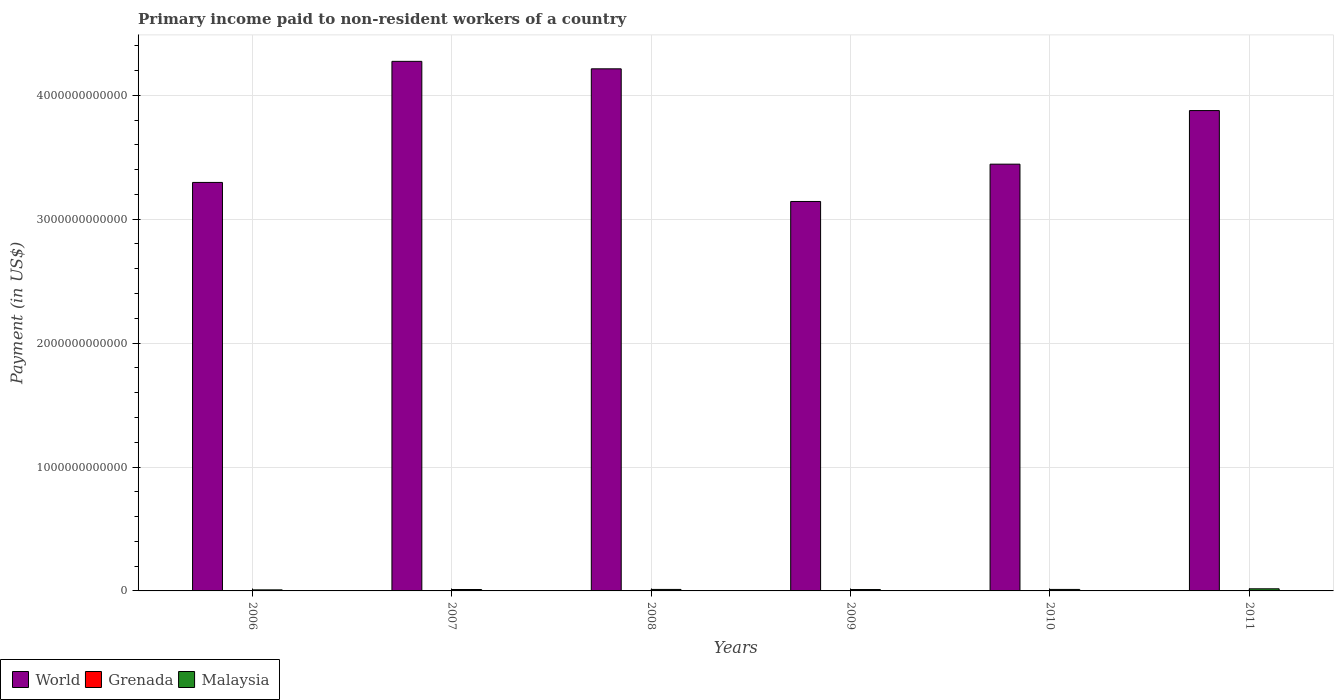How many different coloured bars are there?
Provide a succinct answer. 3. Are the number of bars on each tick of the X-axis equal?
Keep it short and to the point. Yes. How many bars are there on the 4th tick from the right?
Offer a very short reply. 3. What is the amount paid to workers in Grenada in 2007?
Offer a very short reply. 1.37e+07. Across all years, what is the maximum amount paid to workers in Malaysia?
Your answer should be very brief. 1.71e+1. Across all years, what is the minimum amount paid to workers in Malaysia?
Make the answer very short. 8.49e+09. What is the total amount paid to workers in Malaysia in the graph?
Offer a terse response. 7.23e+1. What is the difference between the amount paid to workers in Malaysia in 2009 and that in 2010?
Provide a succinct answer. -7.74e+08. What is the difference between the amount paid to workers in Grenada in 2010 and the amount paid to workers in Malaysia in 2009?
Offer a terse response. -1.12e+1. What is the average amount paid to workers in Grenada per year?
Make the answer very short. 9.34e+06. In the year 2009, what is the difference between the amount paid to workers in World and amount paid to workers in Malaysia?
Offer a very short reply. 3.13e+12. In how many years, is the amount paid to workers in Malaysia greater than 1600000000000 US$?
Keep it short and to the point. 0. What is the ratio of the amount paid to workers in World in 2009 to that in 2010?
Make the answer very short. 0.91. What is the difference between the highest and the second highest amount paid to workers in Grenada?
Provide a short and direct response. 4.04e+05. What is the difference between the highest and the lowest amount paid to workers in Grenada?
Offer a terse response. 7.89e+06. In how many years, is the amount paid to workers in World greater than the average amount paid to workers in World taken over all years?
Make the answer very short. 3. What does the 2nd bar from the left in 2009 represents?
Your answer should be compact. Grenada. What does the 2nd bar from the right in 2010 represents?
Offer a terse response. Grenada. Is it the case that in every year, the sum of the amount paid to workers in Grenada and amount paid to workers in World is greater than the amount paid to workers in Malaysia?
Offer a very short reply. Yes. How many years are there in the graph?
Make the answer very short. 6. What is the difference between two consecutive major ticks on the Y-axis?
Your answer should be very brief. 1.00e+12. Does the graph contain any zero values?
Your answer should be very brief. No. Does the graph contain grids?
Provide a succinct answer. Yes. What is the title of the graph?
Your response must be concise. Primary income paid to non-resident workers of a country. What is the label or title of the Y-axis?
Make the answer very short. Payment (in US$). What is the Payment (in US$) of World in 2006?
Give a very brief answer. 3.30e+12. What is the Payment (in US$) in Grenada in 2006?
Offer a terse response. 1.33e+07. What is the Payment (in US$) in Malaysia in 2006?
Your response must be concise. 8.49e+09. What is the Payment (in US$) in World in 2007?
Your answer should be very brief. 4.27e+12. What is the Payment (in US$) in Grenada in 2007?
Make the answer very short. 1.37e+07. What is the Payment (in US$) in Malaysia in 2007?
Your response must be concise. 1.14e+1. What is the Payment (in US$) of World in 2008?
Provide a short and direct response. 4.21e+12. What is the Payment (in US$) in Grenada in 2008?
Make the answer very short. 8.08e+06. What is the Payment (in US$) in Malaysia in 2008?
Your answer should be very brief. 1.21e+1. What is the Payment (in US$) in World in 2009?
Give a very brief answer. 3.14e+12. What is the Payment (in US$) of Grenada in 2009?
Offer a terse response. 8.12e+06. What is the Payment (in US$) in Malaysia in 2009?
Your answer should be very brief. 1.12e+1. What is the Payment (in US$) in World in 2010?
Provide a succinct answer. 3.44e+12. What is the Payment (in US$) in Grenada in 2010?
Your answer should be compact. 7.15e+06. What is the Payment (in US$) in Malaysia in 2010?
Your response must be concise. 1.20e+1. What is the Payment (in US$) in World in 2011?
Keep it short and to the point. 3.88e+12. What is the Payment (in US$) of Grenada in 2011?
Provide a short and direct response. 5.77e+06. What is the Payment (in US$) of Malaysia in 2011?
Offer a terse response. 1.71e+1. Across all years, what is the maximum Payment (in US$) in World?
Provide a succinct answer. 4.27e+12. Across all years, what is the maximum Payment (in US$) of Grenada?
Your response must be concise. 1.37e+07. Across all years, what is the maximum Payment (in US$) in Malaysia?
Make the answer very short. 1.71e+1. Across all years, what is the minimum Payment (in US$) in World?
Provide a short and direct response. 3.14e+12. Across all years, what is the minimum Payment (in US$) in Grenada?
Offer a very short reply. 5.77e+06. Across all years, what is the minimum Payment (in US$) in Malaysia?
Keep it short and to the point. 8.49e+09. What is the total Payment (in US$) in World in the graph?
Your response must be concise. 2.22e+13. What is the total Payment (in US$) of Grenada in the graph?
Your answer should be compact. 5.60e+07. What is the total Payment (in US$) of Malaysia in the graph?
Ensure brevity in your answer.  7.23e+1. What is the difference between the Payment (in US$) of World in 2006 and that in 2007?
Give a very brief answer. -9.77e+11. What is the difference between the Payment (in US$) of Grenada in 2006 and that in 2007?
Make the answer very short. -4.04e+05. What is the difference between the Payment (in US$) of Malaysia in 2006 and that in 2007?
Give a very brief answer. -2.89e+09. What is the difference between the Payment (in US$) in World in 2006 and that in 2008?
Make the answer very short. -9.17e+11. What is the difference between the Payment (in US$) in Grenada in 2006 and that in 2008?
Make the answer very short. 5.17e+06. What is the difference between the Payment (in US$) in Malaysia in 2006 and that in 2008?
Offer a very short reply. -3.59e+09. What is the difference between the Payment (in US$) in World in 2006 and that in 2009?
Keep it short and to the point. 1.54e+11. What is the difference between the Payment (in US$) in Grenada in 2006 and that in 2009?
Your answer should be compact. 5.13e+06. What is the difference between the Payment (in US$) in Malaysia in 2006 and that in 2009?
Offer a terse response. -2.72e+09. What is the difference between the Payment (in US$) of World in 2006 and that in 2010?
Offer a terse response. -1.47e+11. What is the difference between the Payment (in US$) in Grenada in 2006 and that in 2010?
Your answer should be very brief. 6.10e+06. What is the difference between the Payment (in US$) of Malaysia in 2006 and that in 2010?
Your answer should be very brief. -3.49e+09. What is the difference between the Payment (in US$) in World in 2006 and that in 2011?
Make the answer very short. -5.80e+11. What is the difference between the Payment (in US$) of Grenada in 2006 and that in 2011?
Provide a succinct answer. 7.49e+06. What is the difference between the Payment (in US$) of Malaysia in 2006 and that in 2011?
Give a very brief answer. -8.64e+09. What is the difference between the Payment (in US$) of World in 2007 and that in 2008?
Provide a succinct answer. 6.03e+1. What is the difference between the Payment (in US$) in Grenada in 2007 and that in 2008?
Your answer should be very brief. 5.58e+06. What is the difference between the Payment (in US$) of Malaysia in 2007 and that in 2008?
Ensure brevity in your answer.  -7.01e+08. What is the difference between the Payment (in US$) of World in 2007 and that in 2009?
Your answer should be compact. 1.13e+12. What is the difference between the Payment (in US$) in Grenada in 2007 and that in 2009?
Provide a short and direct response. 5.54e+06. What is the difference between the Payment (in US$) in Malaysia in 2007 and that in 2009?
Your answer should be compact. 1.67e+08. What is the difference between the Payment (in US$) of World in 2007 and that in 2010?
Make the answer very short. 8.30e+11. What is the difference between the Payment (in US$) in Grenada in 2007 and that in 2010?
Your answer should be compact. 6.51e+06. What is the difference between the Payment (in US$) of Malaysia in 2007 and that in 2010?
Ensure brevity in your answer.  -6.07e+08. What is the difference between the Payment (in US$) of World in 2007 and that in 2011?
Ensure brevity in your answer.  3.97e+11. What is the difference between the Payment (in US$) of Grenada in 2007 and that in 2011?
Offer a terse response. 7.89e+06. What is the difference between the Payment (in US$) of Malaysia in 2007 and that in 2011?
Your response must be concise. -5.75e+09. What is the difference between the Payment (in US$) in World in 2008 and that in 2009?
Keep it short and to the point. 1.07e+12. What is the difference between the Payment (in US$) in Grenada in 2008 and that in 2009?
Your answer should be very brief. -4.16e+04. What is the difference between the Payment (in US$) of Malaysia in 2008 and that in 2009?
Offer a terse response. 8.69e+08. What is the difference between the Payment (in US$) in World in 2008 and that in 2010?
Your answer should be very brief. 7.69e+11. What is the difference between the Payment (in US$) of Grenada in 2008 and that in 2010?
Provide a short and direct response. 9.31e+05. What is the difference between the Payment (in US$) of Malaysia in 2008 and that in 2010?
Give a very brief answer. 9.47e+07. What is the difference between the Payment (in US$) in World in 2008 and that in 2011?
Provide a short and direct response. 3.37e+11. What is the difference between the Payment (in US$) of Grenada in 2008 and that in 2011?
Your answer should be compact. 2.31e+06. What is the difference between the Payment (in US$) in Malaysia in 2008 and that in 2011?
Offer a terse response. -5.05e+09. What is the difference between the Payment (in US$) in World in 2009 and that in 2010?
Give a very brief answer. -3.01e+11. What is the difference between the Payment (in US$) of Grenada in 2009 and that in 2010?
Make the answer very short. 9.73e+05. What is the difference between the Payment (in US$) of Malaysia in 2009 and that in 2010?
Give a very brief answer. -7.74e+08. What is the difference between the Payment (in US$) in World in 2009 and that in 2011?
Your response must be concise. -7.34e+11. What is the difference between the Payment (in US$) in Grenada in 2009 and that in 2011?
Your response must be concise. 2.35e+06. What is the difference between the Payment (in US$) of Malaysia in 2009 and that in 2011?
Your answer should be compact. -5.92e+09. What is the difference between the Payment (in US$) in World in 2010 and that in 2011?
Give a very brief answer. -4.33e+11. What is the difference between the Payment (in US$) in Grenada in 2010 and that in 2011?
Your answer should be compact. 1.38e+06. What is the difference between the Payment (in US$) in Malaysia in 2010 and that in 2011?
Offer a very short reply. -5.15e+09. What is the difference between the Payment (in US$) of World in 2006 and the Payment (in US$) of Grenada in 2007?
Your answer should be compact. 3.30e+12. What is the difference between the Payment (in US$) of World in 2006 and the Payment (in US$) of Malaysia in 2007?
Your answer should be very brief. 3.29e+12. What is the difference between the Payment (in US$) of Grenada in 2006 and the Payment (in US$) of Malaysia in 2007?
Ensure brevity in your answer.  -1.14e+1. What is the difference between the Payment (in US$) of World in 2006 and the Payment (in US$) of Grenada in 2008?
Your answer should be compact. 3.30e+12. What is the difference between the Payment (in US$) of World in 2006 and the Payment (in US$) of Malaysia in 2008?
Your answer should be compact. 3.28e+12. What is the difference between the Payment (in US$) in Grenada in 2006 and the Payment (in US$) in Malaysia in 2008?
Keep it short and to the point. -1.21e+1. What is the difference between the Payment (in US$) of World in 2006 and the Payment (in US$) of Grenada in 2009?
Keep it short and to the point. 3.30e+12. What is the difference between the Payment (in US$) of World in 2006 and the Payment (in US$) of Malaysia in 2009?
Keep it short and to the point. 3.29e+12. What is the difference between the Payment (in US$) of Grenada in 2006 and the Payment (in US$) of Malaysia in 2009?
Provide a short and direct response. -1.12e+1. What is the difference between the Payment (in US$) in World in 2006 and the Payment (in US$) in Grenada in 2010?
Ensure brevity in your answer.  3.30e+12. What is the difference between the Payment (in US$) in World in 2006 and the Payment (in US$) in Malaysia in 2010?
Your response must be concise. 3.28e+12. What is the difference between the Payment (in US$) in Grenada in 2006 and the Payment (in US$) in Malaysia in 2010?
Your answer should be very brief. -1.20e+1. What is the difference between the Payment (in US$) of World in 2006 and the Payment (in US$) of Grenada in 2011?
Offer a terse response. 3.30e+12. What is the difference between the Payment (in US$) in World in 2006 and the Payment (in US$) in Malaysia in 2011?
Provide a succinct answer. 3.28e+12. What is the difference between the Payment (in US$) in Grenada in 2006 and the Payment (in US$) in Malaysia in 2011?
Keep it short and to the point. -1.71e+1. What is the difference between the Payment (in US$) of World in 2007 and the Payment (in US$) of Grenada in 2008?
Keep it short and to the point. 4.27e+12. What is the difference between the Payment (in US$) in World in 2007 and the Payment (in US$) in Malaysia in 2008?
Offer a very short reply. 4.26e+12. What is the difference between the Payment (in US$) of Grenada in 2007 and the Payment (in US$) of Malaysia in 2008?
Make the answer very short. -1.21e+1. What is the difference between the Payment (in US$) of World in 2007 and the Payment (in US$) of Grenada in 2009?
Make the answer very short. 4.27e+12. What is the difference between the Payment (in US$) in World in 2007 and the Payment (in US$) in Malaysia in 2009?
Keep it short and to the point. 4.26e+12. What is the difference between the Payment (in US$) in Grenada in 2007 and the Payment (in US$) in Malaysia in 2009?
Provide a short and direct response. -1.12e+1. What is the difference between the Payment (in US$) in World in 2007 and the Payment (in US$) in Grenada in 2010?
Your answer should be very brief. 4.27e+12. What is the difference between the Payment (in US$) of World in 2007 and the Payment (in US$) of Malaysia in 2010?
Your response must be concise. 4.26e+12. What is the difference between the Payment (in US$) in Grenada in 2007 and the Payment (in US$) in Malaysia in 2010?
Ensure brevity in your answer.  -1.20e+1. What is the difference between the Payment (in US$) in World in 2007 and the Payment (in US$) in Grenada in 2011?
Provide a succinct answer. 4.27e+12. What is the difference between the Payment (in US$) of World in 2007 and the Payment (in US$) of Malaysia in 2011?
Keep it short and to the point. 4.26e+12. What is the difference between the Payment (in US$) of Grenada in 2007 and the Payment (in US$) of Malaysia in 2011?
Provide a succinct answer. -1.71e+1. What is the difference between the Payment (in US$) of World in 2008 and the Payment (in US$) of Grenada in 2009?
Your answer should be very brief. 4.21e+12. What is the difference between the Payment (in US$) of World in 2008 and the Payment (in US$) of Malaysia in 2009?
Your response must be concise. 4.20e+12. What is the difference between the Payment (in US$) in Grenada in 2008 and the Payment (in US$) in Malaysia in 2009?
Your response must be concise. -1.12e+1. What is the difference between the Payment (in US$) of World in 2008 and the Payment (in US$) of Grenada in 2010?
Offer a terse response. 4.21e+12. What is the difference between the Payment (in US$) of World in 2008 and the Payment (in US$) of Malaysia in 2010?
Your answer should be compact. 4.20e+12. What is the difference between the Payment (in US$) of Grenada in 2008 and the Payment (in US$) of Malaysia in 2010?
Ensure brevity in your answer.  -1.20e+1. What is the difference between the Payment (in US$) of World in 2008 and the Payment (in US$) of Grenada in 2011?
Keep it short and to the point. 4.21e+12. What is the difference between the Payment (in US$) in World in 2008 and the Payment (in US$) in Malaysia in 2011?
Your answer should be compact. 4.20e+12. What is the difference between the Payment (in US$) of Grenada in 2008 and the Payment (in US$) of Malaysia in 2011?
Offer a very short reply. -1.71e+1. What is the difference between the Payment (in US$) of World in 2009 and the Payment (in US$) of Grenada in 2010?
Make the answer very short. 3.14e+12. What is the difference between the Payment (in US$) in World in 2009 and the Payment (in US$) in Malaysia in 2010?
Keep it short and to the point. 3.13e+12. What is the difference between the Payment (in US$) in Grenada in 2009 and the Payment (in US$) in Malaysia in 2010?
Make the answer very short. -1.20e+1. What is the difference between the Payment (in US$) of World in 2009 and the Payment (in US$) of Grenada in 2011?
Give a very brief answer. 3.14e+12. What is the difference between the Payment (in US$) of World in 2009 and the Payment (in US$) of Malaysia in 2011?
Make the answer very short. 3.13e+12. What is the difference between the Payment (in US$) of Grenada in 2009 and the Payment (in US$) of Malaysia in 2011?
Provide a short and direct response. -1.71e+1. What is the difference between the Payment (in US$) of World in 2010 and the Payment (in US$) of Grenada in 2011?
Provide a succinct answer. 3.44e+12. What is the difference between the Payment (in US$) of World in 2010 and the Payment (in US$) of Malaysia in 2011?
Your response must be concise. 3.43e+12. What is the difference between the Payment (in US$) in Grenada in 2010 and the Payment (in US$) in Malaysia in 2011?
Offer a very short reply. -1.71e+1. What is the average Payment (in US$) of World per year?
Your answer should be compact. 3.71e+12. What is the average Payment (in US$) of Grenada per year?
Your answer should be compact. 9.34e+06. What is the average Payment (in US$) in Malaysia per year?
Ensure brevity in your answer.  1.20e+1. In the year 2006, what is the difference between the Payment (in US$) of World and Payment (in US$) of Grenada?
Provide a succinct answer. 3.30e+12. In the year 2006, what is the difference between the Payment (in US$) in World and Payment (in US$) in Malaysia?
Your answer should be compact. 3.29e+12. In the year 2006, what is the difference between the Payment (in US$) in Grenada and Payment (in US$) in Malaysia?
Your response must be concise. -8.48e+09. In the year 2007, what is the difference between the Payment (in US$) in World and Payment (in US$) in Grenada?
Your answer should be very brief. 4.27e+12. In the year 2007, what is the difference between the Payment (in US$) of World and Payment (in US$) of Malaysia?
Your answer should be compact. 4.26e+12. In the year 2007, what is the difference between the Payment (in US$) of Grenada and Payment (in US$) of Malaysia?
Keep it short and to the point. -1.14e+1. In the year 2008, what is the difference between the Payment (in US$) of World and Payment (in US$) of Grenada?
Give a very brief answer. 4.21e+12. In the year 2008, what is the difference between the Payment (in US$) in World and Payment (in US$) in Malaysia?
Give a very brief answer. 4.20e+12. In the year 2008, what is the difference between the Payment (in US$) of Grenada and Payment (in US$) of Malaysia?
Ensure brevity in your answer.  -1.21e+1. In the year 2009, what is the difference between the Payment (in US$) in World and Payment (in US$) in Grenada?
Provide a succinct answer. 3.14e+12. In the year 2009, what is the difference between the Payment (in US$) in World and Payment (in US$) in Malaysia?
Offer a very short reply. 3.13e+12. In the year 2009, what is the difference between the Payment (in US$) of Grenada and Payment (in US$) of Malaysia?
Ensure brevity in your answer.  -1.12e+1. In the year 2010, what is the difference between the Payment (in US$) of World and Payment (in US$) of Grenada?
Make the answer very short. 3.44e+12. In the year 2010, what is the difference between the Payment (in US$) in World and Payment (in US$) in Malaysia?
Offer a very short reply. 3.43e+12. In the year 2010, what is the difference between the Payment (in US$) in Grenada and Payment (in US$) in Malaysia?
Provide a short and direct response. -1.20e+1. In the year 2011, what is the difference between the Payment (in US$) in World and Payment (in US$) in Grenada?
Ensure brevity in your answer.  3.88e+12. In the year 2011, what is the difference between the Payment (in US$) of World and Payment (in US$) of Malaysia?
Ensure brevity in your answer.  3.86e+12. In the year 2011, what is the difference between the Payment (in US$) of Grenada and Payment (in US$) of Malaysia?
Provide a short and direct response. -1.71e+1. What is the ratio of the Payment (in US$) of World in 2006 to that in 2007?
Provide a short and direct response. 0.77. What is the ratio of the Payment (in US$) of Grenada in 2006 to that in 2007?
Offer a terse response. 0.97. What is the ratio of the Payment (in US$) of Malaysia in 2006 to that in 2007?
Your answer should be very brief. 0.75. What is the ratio of the Payment (in US$) in World in 2006 to that in 2008?
Give a very brief answer. 0.78. What is the ratio of the Payment (in US$) in Grenada in 2006 to that in 2008?
Ensure brevity in your answer.  1.64. What is the ratio of the Payment (in US$) in Malaysia in 2006 to that in 2008?
Make the answer very short. 0.7. What is the ratio of the Payment (in US$) of World in 2006 to that in 2009?
Make the answer very short. 1.05. What is the ratio of the Payment (in US$) in Grenada in 2006 to that in 2009?
Your answer should be compact. 1.63. What is the ratio of the Payment (in US$) in Malaysia in 2006 to that in 2009?
Ensure brevity in your answer.  0.76. What is the ratio of the Payment (in US$) in World in 2006 to that in 2010?
Your response must be concise. 0.96. What is the ratio of the Payment (in US$) of Grenada in 2006 to that in 2010?
Your answer should be very brief. 1.85. What is the ratio of the Payment (in US$) in Malaysia in 2006 to that in 2010?
Your answer should be compact. 0.71. What is the ratio of the Payment (in US$) in World in 2006 to that in 2011?
Provide a succinct answer. 0.85. What is the ratio of the Payment (in US$) in Grenada in 2006 to that in 2011?
Keep it short and to the point. 2.3. What is the ratio of the Payment (in US$) in Malaysia in 2006 to that in 2011?
Ensure brevity in your answer.  0.5. What is the ratio of the Payment (in US$) in World in 2007 to that in 2008?
Offer a terse response. 1.01. What is the ratio of the Payment (in US$) of Grenada in 2007 to that in 2008?
Your answer should be compact. 1.69. What is the ratio of the Payment (in US$) of Malaysia in 2007 to that in 2008?
Your answer should be compact. 0.94. What is the ratio of the Payment (in US$) of World in 2007 to that in 2009?
Make the answer very short. 1.36. What is the ratio of the Payment (in US$) in Grenada in 2007 to that in 2009?
Keep it short and to the point. 1.68. What is the ratio of the Payment (in US$) in Malaysia in 2007 to that in 2009?
Keep it short and to the point. 1.01. What is the ratio of the Payment (in US$) in World in 2007 to that in 2010?
Keep it short and to the point. 1.24. What is the ratio of the Payment (in US$) of Grenada in 2007 to that in 2010?
Provide a succinct answer. 1.91. What is the ratio of the Payment (in US$) of Malaysia in 2007 to that in 2010?
Offer a very short reply. 0.95. What is the ratio of the Payment (in US$) in World in 2007 to that in 2011?
Ensure brevity in your answer.  1.1. What is the ratio of the Payment (in US$) in Grenada in 2007 to that in 2011?
Keep it short and to the point. 2.37. What is the ratio of the Payment (in US$) in Malaysia in 2007 to that in 2011?
Your answer should be compact. 0.66. What is the ratio of the Payment (in US$) of World in 2008 to that in 2009?
Ensure brevity in your answer.  1.34. What is the ratio of the Payment (in US$) of Grenada in 2008 to that in 2009?
Give a very brief answer. 0.99. What is the ratio of the Payment (in US$) of Malaysia in 2008 to that in 2009?
Your response must be concise. 1.08. What is the ratio of the Payment (in US$) in World in 2008 to that in 2010?
Provide a short and direct response. 1.22. What is the ratio of the Payment (in US$) of Grenada in 2008 to that in 2010?
Your answer should be very brief. 1.13. What is the ratio of the Payment (in US$) of Malaysia in 2008 to that in 2010?
Give a very brief answer. 1.01. What is the ratio of the Payment (in US$) in World in 2008 to that in 2011?
Ensure brevity in your answer.  1.09. What is the ratio of the Payment (in US$) in Grenada in 2008 to that in 2011?
Your answer should be compact. 1.4. What is the ratio of the Payment (in US$) in Malaysia in 2008 to that in 2011?
Give a very brief answer. 0.71. What is the ratio of the Payment (in US$) in World in 2009 to that in 2010?
Your answer should be compact. 0.91. What is the ratio of the Payment (in US$) of Grenada in 2009 to that in 2010?
Give a very brief answer. 1.14. What is the ratio of the Payment (in US$) in Malaysia in 2009 to that in 2010?
Offer a terse response. 0.94. What is the ratio of the Payment (in US$) of World in 2009 to that in 2011?
Your answer should be compact. 0.81. What is the ratio of the Payment (in US$) in Grenada in 2009 to that in 2011?
Provide a short and direct response. 1.41. What is the ratio of the Payment (in US$) of Malaysia in 2009 to that in 2011?
Provide a short and direct response. 0.65. What is the ratio of the Payment (in US$) in World in 2010 to that in 2011?
Provide a short and direct response. 0.89. What is the ratio of the Payment (in US$) in Grenada in 2010 to that in 2011?
Provide a short and direct response. 1.24. What is the ratio of the Payment (in US$) in Malaysia in 2010 to that in 2011?
Your response must be concise. 0.7. What is the difference between the highest and the second highest Payment (in US$) in World?
Ensure brevity in your answer.  6.03e+1. What is the difference between the highest and the second highest Payment (in US$) in Grenada?
Keep it short and to the point. 4.04e+05. What is the difference between the highest and the second highest Payment (in US$) of Malaysia?
Ensure brevity in your answer.  5.05e+09. What is the difference between the highest and the lowest Payment (in US$) in World?
Your response must be concise. 1.13e+12. What is the difference between the highest and the lowest Payment (in US$) of Grenada?
Your answer should be very brief. 7.89e+06. What is the difference between the highest and the lowest Payment (in US$) in Malaysia?
Your answer should be very brief. 8.64e+09. 